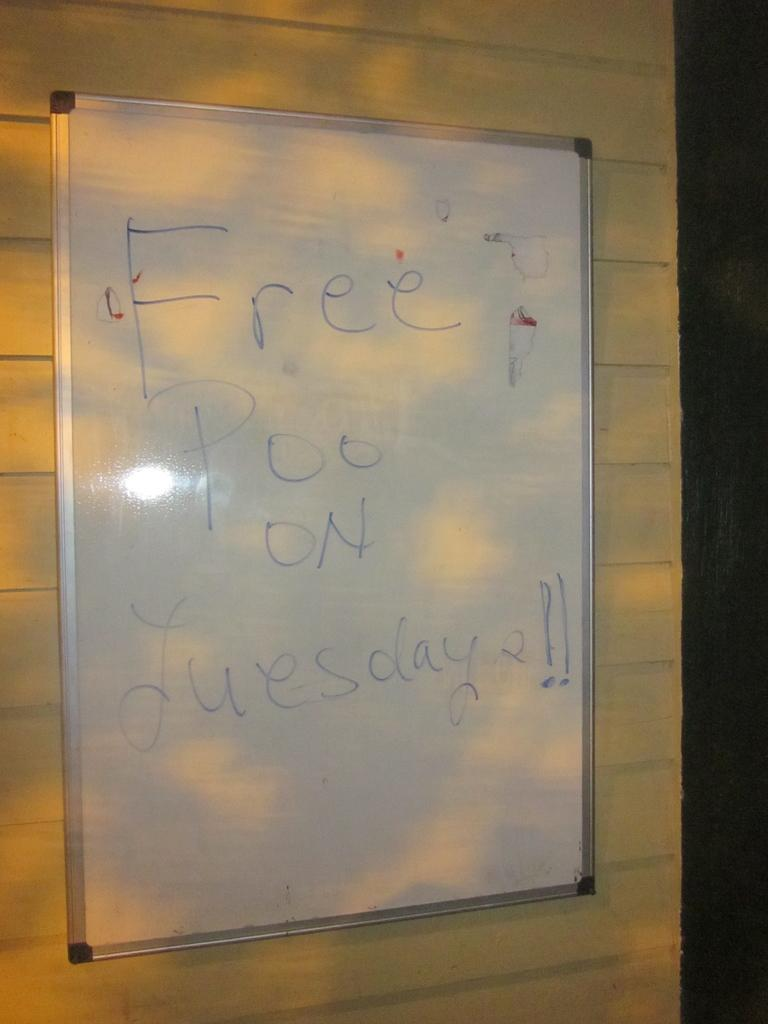Provide a one-sentence caption for the provided image. A whiteboard on a wall that says Free Poo on Tuesday. 